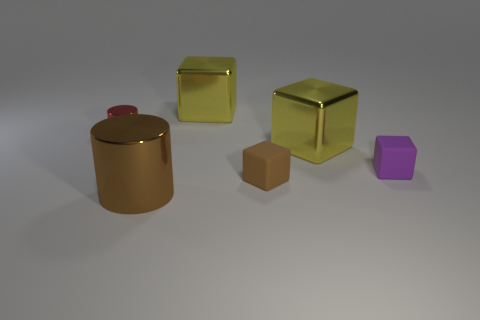Subtract all yellow cubes. How many were subtracted if there are1yellow cubes left? 1 Subtract all brown cubes. How many cubes are left? 3 Subtract all purple blocks. How many blocks are left? 3 Subtract all cylinders. How many objects are left? 4 Subtract 4 cubes. How many cubes are left? 0 Subtract all green cylinders. How many brown blocks are left? 1 Subtract all small cubes. Subtract all tiny brown matte objects. How many objects are left? 3 Add 1 brown metallic cylinders. How many brown metallic cylinders are left? 2 Add 1 red cylinders. How many red cylinders exist? 2 Add 4 large gray matte spheres. How many objects exist? 10 